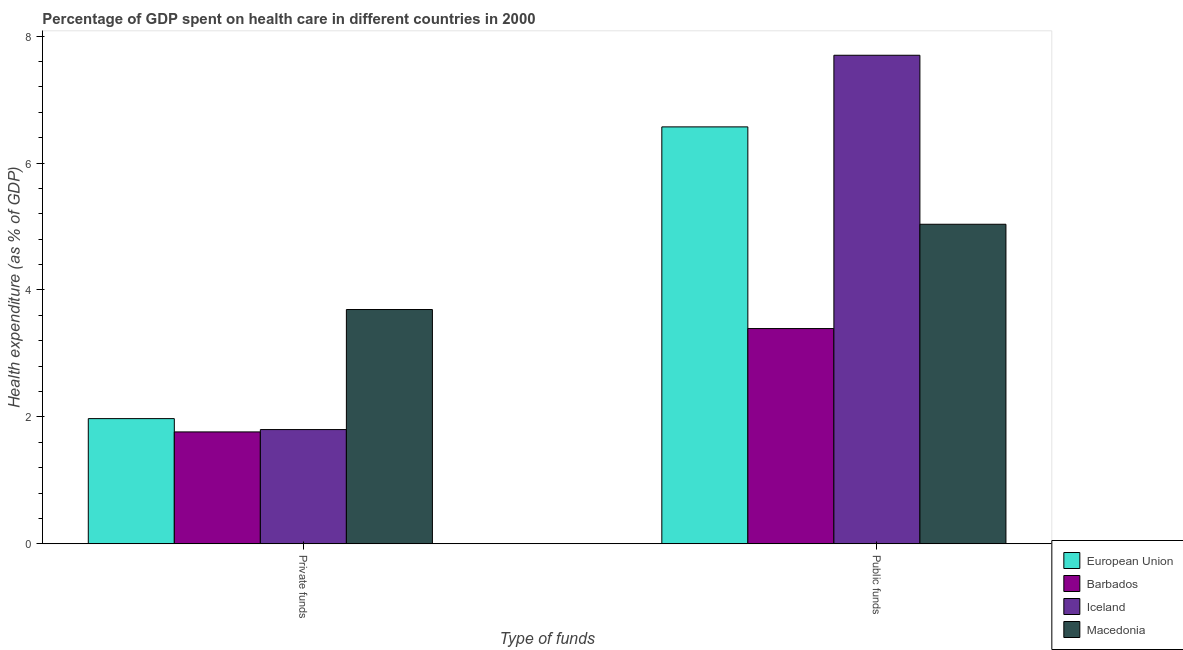How many groups of bars are there?
Your response must be concise. 2. Are the number of bars per tick equal to the number of legend labels?
Give a very brief answer. Yes. Are the number of bars on each tick of the X-axis equal?
Your answer should be compact. Yes. How many bars are there on the 1st tick from the right?
Make the answer very short. 4. What is the label of the 2nd group of bars from the left?
Ensure brevity in your answer.  Public funds. What is the amount of private funds spent in healthcare in Macedonia?
Your answer should be very brief. 3.69. Across all countries, what is the maximum amount of private funds spent in healthcare?
Offer a very short reply. 3.69. Across all countries, what is the minimum amount of public funds spent in healthcare?
Keep it short and to the point. 3.39. In which country was the amount of private funds spent in healthcare maximum?
Your answer should be very brief. Macedonia. In which country was the amount of public funds spent in healthcare minimum?
Make the answer very short. Barbados. What is the total amount of private funds spent in healthcare in the graph?
Your answer should be compact. 9.23. What is the difference between the amount of public funds spent in healthcare in Iceland and that in European Union?
Provide a succinct answer. 1.13. What is the difference between the amount of private funds spent in healthcare in Macedonia and the amount of public funds spent in healthcare in European Union?
Your answer should be very brief. -2.88. What is the average amount of public funds spent in healthcare per country?
Provide a short and direct response. 5.67. What is the difference between the amount of public funds spent in healthcare and amount of private funds spent in healthcare in Macedonia?
Give a very brief answer. 1.34. In how many countries, is the amount of public funds spent in healthcare greater than 7.2 %?
Offer a very short reply. 1. What is the ratio of the amount of public funds spent in healthcare in Macedonia to that in Iceland?
Your response must be concise. 0.65. Is the amount of public funds spent in healthcare in European Union less than that in Macedonia?
Offer a terse response. No. In how many countries, is the amount of private funds spent in healthcare greater than the average amount of private funds spent in healthcare taken over all countries?
Ensure brevity in your answer.  1. What does the 2nd bar from the left in Private funds represents?
Offer a very short reply. Barbados. What does the 4th bar from the right in Public funds represents?
Keep it short and to the point. European Union. Are all the bars in the graph horizontal?
Provide a succinct answer. No. How many countries are there in the graph?
Your answer should be very brief. 4. What is the difference between two consecutive major ticks on the Y-axis?
Your response must be concise. 2. Does the graph contain any zero values?
Provide a short and direct response. No. Where does the legend appear in the graph?
Your response must be concise. Bottom right. What is the title of the graph?
Give a very brief answer. Percentage of GDP spent on health care in different countries in 2000. What is the label or title of the X-axis?
Provide a short and direct response. Type of funds. What is the label or title of the Y-axis?
Keep it short and to the point. Health expenditure (as % of GDP). What is the Health expenditure (as % of GDP) in European Union in Private funds?
Offer a terse response. 1.97. What is the Health expenditure (as % of GDP) of Barbados in Private funds?
Ensure brevity in your answer.  1.76. What is the Health expenditure (as % of GDP) in Iceland in Private funds?
Ensure brevity in your answer.  1.8. What is the Health expenditure (as % of GDP) of Macedonia in Private funds?
Provide a succinct answer. 3.69. What is the Health expenditure (as % of GDP) of European Union in Public funds?
Offer a terse response. 6.57. What is the Health expenditure (as % of GDP) of Barbados in Public funds?
Your answer should be compact. 3.39. What is the Health expenditure (as % of GDP) of Iceland in Public funds?
Make the answer very short. 7.7. What is the Health expenditure (as % of GDP) in Macedonia in Public funds?
Your answer should be very brief. 5.04. Across all Type of funds, what is the maximum Health expenditure (as % of GDP) of European Union?
Provide a short and direct response. 6.57. Across all Type of funds, what is the maximum Health expenditure (as % of GDP) of Barbados?
Provide a succinct answer. 3.39. Across all Type of funds, what is the maximum Health expenditure (as % of GDP) in Iceland?
Your answer should be compact. 7.7. Across all Type of funds, what is the maximum Health expenditure (as % of GDP) in Macedonia?
Offer a terse response. 5.04. Across all Type of funds, what is the minimum Health expenditure (as % of GDP) of European Union?
Ensure brevity in your answer.  1.97. Across all Type of funds, what is the minimum Health expenditure (as % of GDP) of Barbados?
Offer a very short reply. 1.76. Across all Type of funds, what is the minimum Health expenditure (as % of GDP) of Iceland?
Your answer should be compact. 1.8. Across all Type of funds, what is the minimum Health expenditure (as % of GDP) in Macedonia?
Provide a short and direct response. 3.69. What is the total Health expenditure (as % of GDP) in European Union in the graph?
Ensure brevity in your answer.  8.54. What is the total Health expenditure (as % of GDP) of Barbados in the graph?
Offer a very short reply. 5.16. What is the total Health expenditure (as % of GDP) in Iceland in the graph?
Provide a short and direct response. 9.5. What is the total Health expenditure (as % of GDP) of Macedonia in the graph?
Offer a very short reply. 8.73. What is the difference between the Health expenditure (as % of GDP) of European Union in Private funds and that in Public funds?
Give a very brief answer. -4.6. What is the difference between the Health expenditure (as % of GDP) in Barbados in Private funds and that in Public funds?
Provide a succinct answer. -1.63. What is the difference between the Health expenditure (as % of GDP) of Iceland in Private funds and that in Public funds?
Your answer should be compact. -5.9. What is the difference between the Health expenditure (as % of GDP) in Macedonia in Private funds and that in Public funds?
Offer a terse response. -1.34. What is the difference between the Health expenditure (as % of GDP) of European Union in Private funds and the Health expenditure (as % of GDP) of Barbados in Public funds?
Provide a succinct answer. -1.42. What is the difference between the Health expenditure (as % of GDP) of European Union in Private funds and the Health expenditure (as % of GDP) of Iceland in Public funds?
Make the answer very short. -5.73. What is the difference between the Health expenditure (as % of GDP) in European Union in Private funds and the Health expenditure (as % of GDP) in Macedonia in Public funds?
Keep it short and to the point. -3.06. What is the difference between the Health expenditure (as % of GDP) of Barbados in Private funds and the Health expenditure (as % of GDP) of Iceland in Public funds?
Your answer should be very brief. -5.94. What is the difference between the Health expenditure (as % of GDP) in Barbados in Private funds and the Health expenditure (as % of GDP) in Macedonia in Public funds?
Give a very brief answer. -3.27. What is the difference between the Health expenditure (as % of GDP) in Iceland in Private funds and the Health expenditure (as % of GDP) in Macedonia in Public funds?
Your answer should be compact. -3.24. What is the average Health expenditure (as % of GDP) of European Union per Type of funds?
Make the answer very short. 4.27. What is the average Health expenditure (as % of GDP) of Barbados per Type of funds?
Make the answer very short. 2.58. What is the average Health expenditure (as % of GDP) in Iceland per Type of funds?
Offer a terse response. 4.75. What is the average Health expenditure (as % of GDP) of Macedonia per Type of funds?
Ensure brevity in your answer.  4.36. What is the difference between the Health expenditure (as % of GDP) of European Union and Health expenditure (as % of GDP) of Barbados in Private funds?
Provide a succinct answer. 0.21. What is the difference between the Health expenditure (as % of GDP) of European Union and Health expenditure (as % of GDP) of Iceland in Private funds?
Your answer should be very brief. 0.17. What is the difference between the Health expenditure (as % of GDP) in European Union and Health expenditure (as % of GDP) in Macedonia in Private funds?
Offer a very short reply. -1.72. What is the difference between the Health expenditure (as % of GDP) of Barbados and Health expenditure (as % of GDP) of Iceland in Private funds?
Offer a very short reply. -0.04. What is the difference between the Health expenditure (as % of GDP) of Barbados and Health expenditure (as % of GDP) of Macedonia in Private funds?
Keep it short and to the point. -1.93. What is the difference between the Health expenditure (as % of GDP) in Iceland and Health expenditure (as % of GDP) in Macedonia in Private funds?
Make the answer very short. -1.89. What is the difference between the Health expenditure (as % of GDP) in European Union and Health expenditure (as % of GDP) in Barbados in Public funds?
Give a very brief answer. 3.18. What is the difference between the Health expenditure (as % of GDP) in European Union and Health expenditure (as % of GDP) in Iceland in Public funds?
Your answer should be very brief. -1.13. What is the difference between the Health expenditure (as % of GDP) in European Union and Health expenditure (as % of GDP) in Macedonia in Public funds?
Offer a very short reply. 1.53. What is the difference between the Health expenditure (as % of GDP) of Barbados and Health expenditure (as % of GDP) of Iceland in Public funds?
Offer a very short reply. -4.31. What is the difference between the Health expenditure (as % of GDP) of Barbados and Health expenditure (as % of GDP) of Macedonia in Public funds?
Provide a short and direct response. -1.64. What is the difference between the Health expenditure (as % of GDP) in Iceland and Health expenditure (as % of GDP) in Macedonia in Public funds?
Your response must be concise. 2.66. What is the ratio of the Health expenditure (as % of GDP) in European Union in Private funds to that in Public funds?
Offer a very short reply. 0.3. What is the ratio of the Health expenditure (as % of GDP) of Barbados in Private funds to that in Public funds?
Your answer should be very brief. 0.52. What is the ratio of the Health expenditure (as % of GDP) of Iceland in Private funds to that in Public funds?
Offer a very short reply. 0.23. What is the ratio of the Health expenditure (as % of GDP) in Macedonia in Private funds to that in Public funds?
Give a very brief answer. 0.73. What is the difference between the highest and the second highest Health expenditure (as % of GDP) of European Union?
Give a very brief answer. 4.6. What is the difference between the highest and the second highest Health expenditure (as % of GDP) of Barbados?
Ensure brevity in your answer.  1.63. What is the difference between the highest and the second highest Health expenditure (as % of GDP) of Iceland?
Your response must be concise. 5.9. What is the difference between the highest and the second highest Health expenditure (as % of GDP) in Macedonia?
Provide a succinct answer. 1.34. What is the difference between the highest and the lowest Health expenditure (as % of GDP) in European Union?
Provide a short and direct response. 4.6. What is the difference between the highest and the lowest Health expenditure (as % of GDP) of Barbados?
Ensure brevity in your answer.  1.63. What is the difference between the highest and the lowest Health expenditure (as % of GDP) of Iceland?
Offer a terse response. 5.9. What is the difference between the highest and the lowest Health expenditure (as % of GDP) of Macedonia?
Offer a terse response. 1.34. 